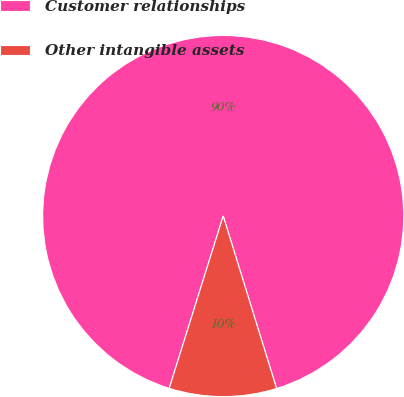Convert chart to OTSL. <chart><loc_0><loc_0><loc_500><loc_500><pie_chart><fcel>Customer relationships<fcel>Other intangible assets<nl><fcel>90.39%<fcel>9.61%<nl></chart> 